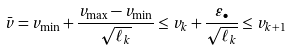<formula> <loc_0><loc_0><loc_500><loc_500>\bar { v } = v _ { \min } + \frac { v _ { \max } - v _ { \min } } { \sqrt { \ell _ { k } } } \leq v _ { k } + \frac { \varepsilon _ { \bullet } } { \sqrt { \ell _ { k } } } \leq v _ { k + 1 }</formula> 